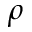<formula> <loc_0><loc_0><loc_500><loc_500>\rho</formula> 